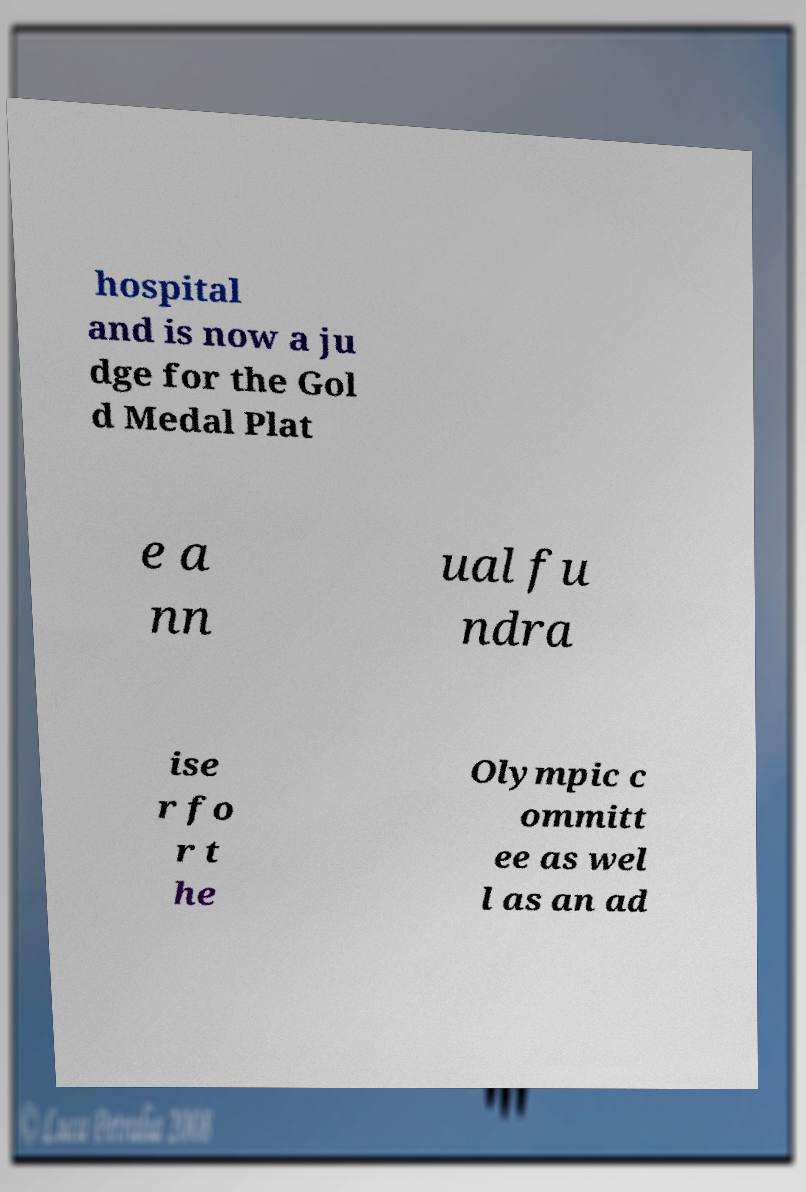Could you extract and type out the text from this image? hospital and is now a ju dge for the Gol d Medal Plat e a nn ual fu ndra ise r fo r t he Olympic c ommitt ee as wel l as an ad 